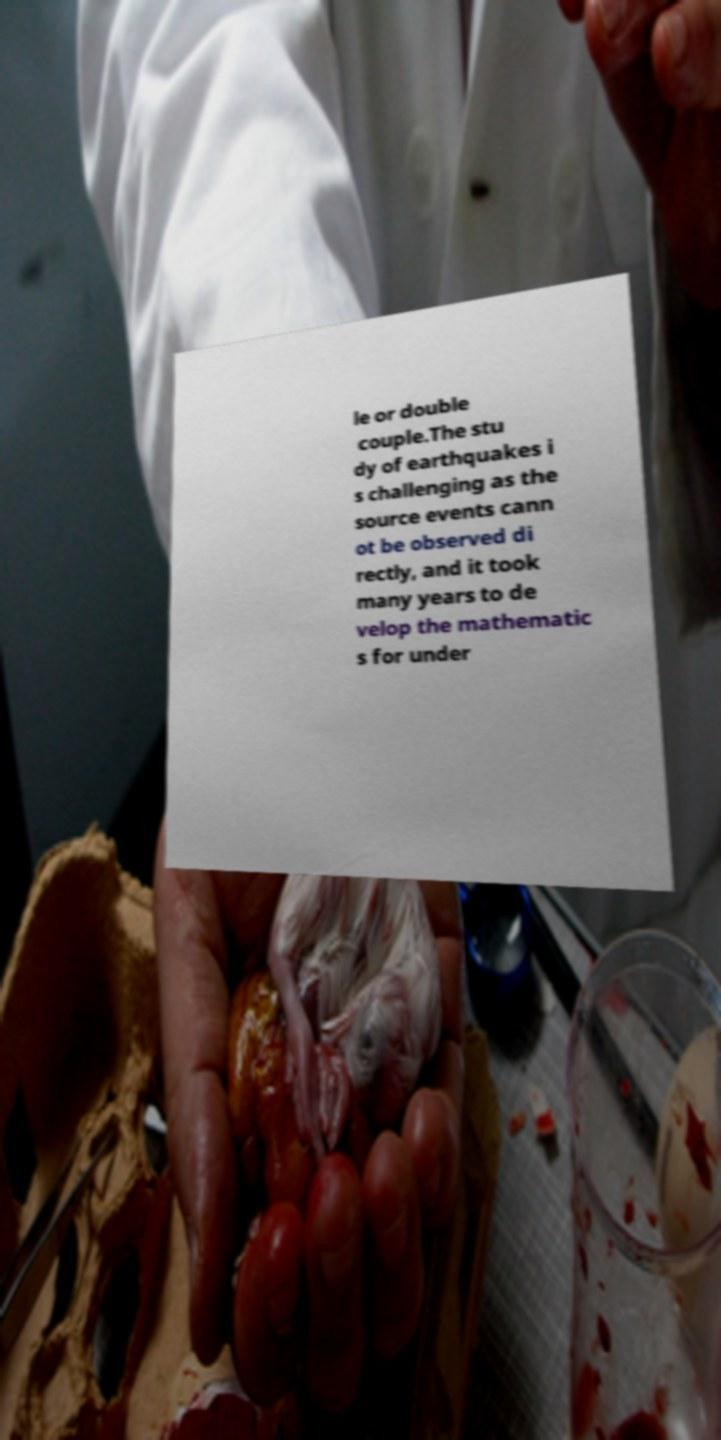For documentation purposes, I need the text within this image transcribed. Could you provide that? le or double couple.The stu dy of earthquakes i s challenging as the source events cann ot be observed di rectly, and it took many years to de velop the mathematic s for under 